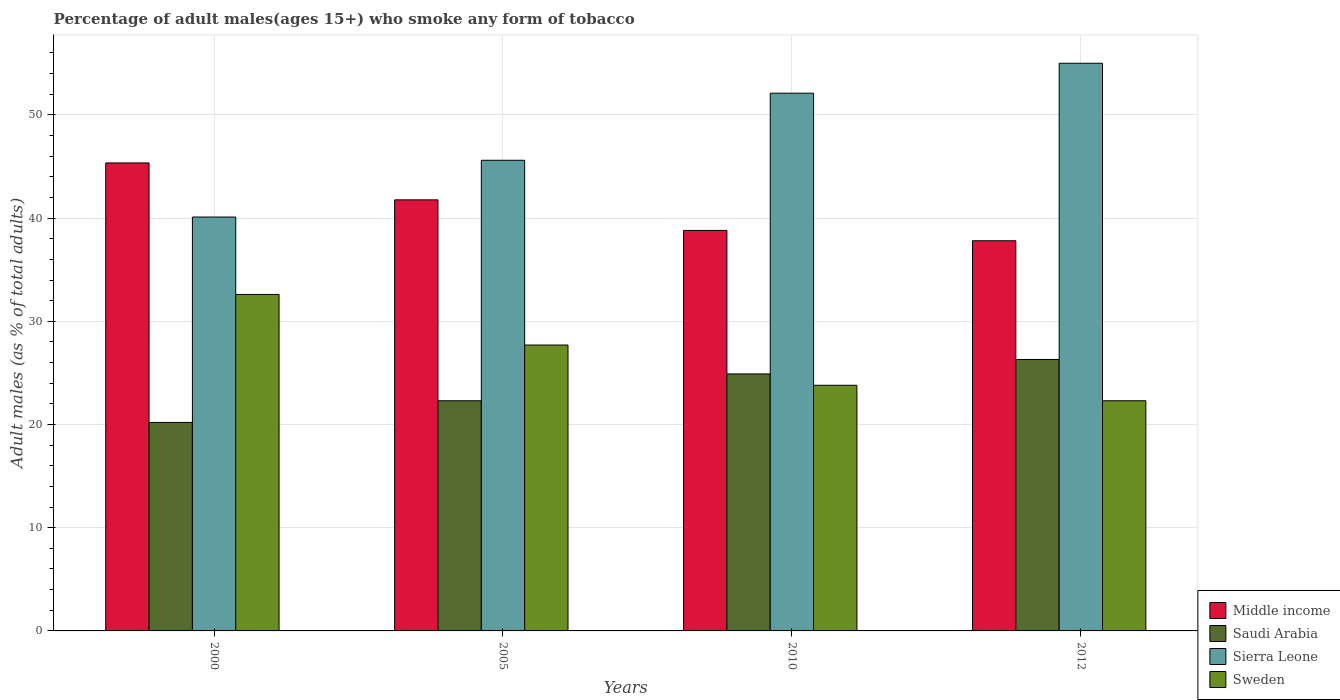Are the number of bars per tick equal to the number of legend labels?
Make the answer very short. Yes. Are the number of bars on each tick of the X-axis equal?
Your answer should be compact. Yes. How many bars are there on the 3rd tick from the right?
Your answer should be compact. 4. What is the label of the 3rd group of bars from the left?
Provide a succinct answer. 2010. What is the percentage of adult males who smoke in Sweden in 2000?
Make the answer very short. 32.6. Across all years, what is the maximum percentage of adult males who smoke in Saudi Arabia?
Your answer should be compact. 26.3. Across all years, what is the minimum percentage of adult males who smoke in Sweden?
Your answer should be very brief. 22.3. In which year was the percentage of adult males who smoke in Sierra Leone maximum?
Offer a very short reply. 2012. What is the total percentage of adult males who smoke in Middle income in the graph?
Provide a short and direct response. 163.71. What is the difference between the percentage of adult males who smoke in Sierra Leone in 2000 and the percentage of adult males who smoke in Sweden in 2005?
Your response must be concise. 12.4. What is the average percentage of adult males who smoke in Sierra Leone per year?
Ensure brevity in your answer.  48.2. In the year 2010, what is the difference between the percentage of adult males who smoke in Sweden and percentage of adult males who smoke in Sierra Leone?
Make the answer very short. -28.3. In how many years, is the percentage of adult males who smoke in Sierra Leone greater than 24 %?
Offer a terse response. 4. What is the ratio of the percentage of adult males who smoke in Sierra Leone in 2000 to that in 2010?
Provide a short and direct response. 0.77. Is the difference between the percentage of adult males who smoke in Sweden in 2000 and 2005 greater than the difference between the percentage of adult males who smoke in Sierra Leone in 2000 and 2005?
Ensure brevity in your answer.  Yes. What is the difference between the highest and the second highest percentage of adult males who smoke in Saudi Arabia?
Ensure brevity in your answer.  1.4. What is the difference between the highest and the lowest percentage of adult males who smoke in Sierra Leone?
Provide a succinct answer. 14.9. In how many years, is the percentage of adult males who smoke in Saudi Arabia greater than the average percentage of adult males who smoke in Saudi Arabia taken over all years?
Your response must be concise. 2. What does the 2nd bar from the left in 2012 represents?
Your answer should be compact. Saudi Arabia. What does the 2nd bar from the right in 2005 represents?
Offer a very short reply. Sierra Leone. How many bars are there?
Make the answer very short. 16. How many years are there in the graph?
Ensure brevity in your answer.  4. Are the values on the major ticks of Y-axis written in scientific E-notation?
Your answer should be very brief. No. Where does the legend appear in the graph?
Give a very brief answer. Bottom right. How many legend labels are there?
Ensure brevity in your answer.  4. What is the title of the graph?
Keep it short and to the point. Percentage of adult males(ages 15+) who smoke any form of tobacco. Does "Libya" appear as one of the legend labels in the graph?
Your answer should be compact. No. What is the label or title of the X-axis?
Make the answer very short. Years. What is the label or title of the Y-axis?
Keep it short and to the point. Adult males (as % of total adults). What is the Adult males (as % of total adults) in Middle income in 2000?
Your response must be concise. 45.34. What is the Adult males (as % of total adults) in Saudi Arabia in 2000?
Ensure brevity in your answer.  20.2. What is the Adult males (as % of total adults) of Sierra Leone in 2000?
Your answer should be very brief. 40.1. What is the Adult males (as % of total adults) in Sweden in 2000?
Your response must be concise. 32.6. What is the Adult males (as % of total adults) in Middle income in 2005?
Give a very brief answer. 41.77. What is the Adult males (as % of total adults) of Saudi Arabia in 2005?
Provide a short and direct response. 22.3. What is the Adult males (as % of total adults) in Sierra Leone in 2005?
Your answer should be compact. 45.6. What is the Adult males (as % of total adults) of Sweden in 2005?
Make the answer very short. 27.7. What is the Adult males (as % of total adults) of Middle income in 2010?
Provide a succinct answer. 38.8. What is the Adult males (as % of total adults) of Saudi Arabia in 2010?
Your answer should be very brief. 24.9. What is the Adult males (as % of total adults) in Sierra Leone in 2010?
Make the answer very short. 52.1. What is the Adult males (as % of total adults) of Sweden in 2010?
Provide a short and direct response. 23.8. What is the Adult males (as % of total adults) in Middle income in 2012?
Make the answer very short. 37.8. What is the Adult males (as % of total adults) of Saudi Arabia in 2012?
Keep it short and to the point. 26.3. What is the Adult males (as % of total adults) of Sierra Leone in 2012?
Provide a short and direct response. 55. What is the Adult males (as % of total adults) in Sweden in 2012?
Provide a succinct answer. 22.3. Across all years, what is the maximum Adult males (as % of total adults) of Middle income?
Make the answer very short. 45.34. Across all years, what is the maximum Adult males (as % of total adults) of Saudi Arabia?
Offer a very short reply. 26.3. Across all years, what is the maximum Adult males (as % of total adults) of Sweden?
Provide a short and direct response. 32.6. Across all years, what is the minimum Adult males (as % of total adults) of Middle income?
Provide a short and direct response. 37.8. Across all years, what is the minimum Adult males (as % of total adults) in Saudi Arabia?
Give a very brief answer. 20.2. Across all years, what is the minimum Adult males (as % of total adults) of Sierra Leone?
Offer a terse response. 40.1. Across all years, what is the minimum Adult males (as % of total adults) of Sweden?
Offer a terse response. 22.3. What is the total Adult males (as % of total adults) in Middle income in the graph?
Offer a terse response. 163.71. What is the total Adult males (as % of total adults) of Saudi Arabia in the graph?
Your answer should be very brief. 93.7. What is the total Adult males (as % of total adults) of Sierra Leone in the graph?
Offer a very short reply. 192.8. What is the total Adult males (as % of total adults) of Sweden in the graph?
Keep it short and to the point. 106.4. What is the difference between the Adult males (as % of total adults) in Middle income in 2000 and that in 2005?
Your answer should be compact. 3.58. What is the difference between the Adult males (as % of total adults) in Saudi Arabia in 2000 and that in 2005?
Ensure brevity in your answer.  -2.1. What is the difference between the Adult males (as % of total adults) in Sweden in 2000 and that in 2005?
Your answer should be very brief. 4.9. What is the difference between the Adult males (as % of total adults) of Middle income in 2000 and that in 2010?
Offer a very short reply. 6.54. What is the difference between the Adult males (as % of total adults) in Sierra Leone in 2000 and that in 2010?
Keep it short and to the point. -12. What is the difference between the Adult males (as % of total adults) in Middle income in 2000 and that in 2012?
Provide a short and direct response. 7.54. What is the difference between the Adult males (as % of total adults) in Sierra Leone in 2000 and that in 2012?
Give a very brief answer. -14.9. What is the difference between the Adult males (as % of total adults) in Middle income in 2005 and that in 2010?
Offer a terse response. 2.96. What is the difference between the Adult males (as % of total adults) of Saudi Arabia in 2005 and that in 2010?
Offer a very short reply. -2.6. What is the difference between the Adult males (as % of total adults) of Sierra Leone in 2005 and that in 2010?
Your response must be concise. -6.5. What is the difference between the Adult males (as % of total adults) in Middle income in 2005 and that in 2012?
Give a very brief answer. 3.96. What is the difference between the Adult males (as % of total adults) of Sierra Leone in 2005 and that in 2012?
Provide a succinct answer. -9.4. What is the difference between the Adult males (as % of total adults) of Middle income in 2000 and the Adult males (as % of total adults) of Saudi Arabia in 2005?
Your response must be concise. 23.04. What is the difference between the Adult males (as % of total adults) in Middle income in 2000 and the Adult males (as % of total adults) in Sierra Leone in 2005?
Keep it short and to the point. -0.26. What is the difference between the Adult males (as % of total adults) of Middle income in 2000 and the Adult males (as % of total adults) of Sweden in 2005?
Your answer should be very brief. 17.64. What is the difference between the Adult males (as % of total adults) in Saudi Arabia in 2000 and the Adult males (as % of total adults) in Sierra Leone in 2005?
Ensure brevity in your answer.  -25.4. What is the difference between the Adult males (as % of total adults) in Middle income in 2000 and the Adult males (as % of total adults) in Saudi Arabia in 2010?
Keep it short and to the point. 20.44. What is the difference between the Adult males (as % of total adults) of Middle income in 2000 and the Adult males (as % of total adults) of Sierra Leone in 2010?
Make the answer very short. -6.76. What is the difference between the Adult males (as % of total adults) of Middle income in 2000 and the Adult males (as % of total adults) of Sweden in 2010?
Your answer should be very brief. 21.54. What is the difference between the Adult males (as % of total adults) in Saudi Arabia in 2000 and the Adult males (as % of total adults) in Sierra Leone in 2010?
Ensure brevity in your answer.  -31.9. What is the difference between the Adult males (as % of total adults) in Saudi Arabia in 2000 and the Adult males (as % of total adults) in Sweden in 2010?
Your answer should be very brief. -3.6. What is the difference between the Adult males (as % of total adults) in Middle income in 2000 and the Adult males (as % of total adults) in Saudi Arabia in 2012?
Make the answer very short. 19.04. What is the difference between the Adult males (as % of total adults) in Middle income in 2000 and the Adult males (as % of total adults) in Sierra Leone in 2012?
Offer a very short reply. -9.66. What is the difference between the Adult males (as % of total adults) in Middle income in 2000 and the Adult males (as % of total adults) in Sweden in 2012?
Give a very brief answer. 23.04. What is the difference between the Adult males (as % of total adults) of Saudi Arabia in 2000 and the Adult males (as % of total adults) of Sierra Leone in 2012?
Provide a succinct answer. -34.8. What is the difference between the Adult males (as % of total adults) in Saudi Arabia in 2000 and the Adult males (as % of total adults) in Sweden in 2012?
Offer a terse response. -2.1. What is the difference between the Adult males (as % of total adults) in Middle income in 2005 and the Adult males (as % of total adults) in Saudi Arabia in 2010?
Provide a succinct answer. 16.87. What is the difference between the Adult males (as % of total adults) of Middle income in 2005 and the Adult males (as % of total adults) of Sierra Leone in 2010?
Keep it short and to the point. -10.33. What is the difference between the Adult males (as % of total adults) of Middle income in 2005 and the Adult males (as % of total adults) of Sweden in 2010?
Keep it short and to the point. 17.97. What is the difference between the Adult males (as % of total adults) in Saudi Arabia in 2005 and the Adult males (as % of total adults) in Sierra Leone in 2010?
Make the answer very short. -29.8. What is the difference between the Adult males (as % of total adults) of Sierra Leone in 2005 and the Adult males (as % of total adults) of Sweden in 2010?
Offer a very short reply. 21.8. What is the difference between the Adult males (as % of total adults) of Middle income in 2005 and the Adult males (as % of total adults) of Saudi Arabia in 2012?
Offer a very short reply. 15.47. What is the difference between the Adult males (as % of total adults) in Middle income in 2005 and the Adult males (as % of total adults) in Sierra Leone in 2012?
Your answer should be compact. -13.23. What is the difference between the Adult males (as % of total adults) of Middle income in 2005 and the Adult males (as % of total adults) of Sweden in 2012?
Give a very brief answer. 19.47. What is the difference between the Adult males (as % of total adults) of Saudi Arabia in 2005 and the Adult males (as % of total adults) of Sierra Leone in 2012?
Give a very brief answer. -32.7. What is the difference between the Adult males (as % of total adults) of Sierra Leone in 2005 and the Adult males (as % of total adults) of Sweden in 2012?
Give a very brief answer. 23.3. What is the difference between the Adult males (as % of total adults) in Middle income in 2010 and the Adult males (as % of total adults) in Saudi Arabia in 2012?
Your answer should be compact. 12.5. What is the difference between the Adult males (as % of total adults) in Middle income in 2010 and the Adult males (as % of total adults) in Sierra Leone in 2012?
Make the answer very short. -16.2. What is the difference between the Adult males (as % of total adults) in Middle income in 2010 and the Adult males (as % of total adults) in Sweden in 2012?
Offer a terse response. 16.5. What is the difference between the Adult males (as % of total adults) of Saudi Arabia in 2010 and the Adult males (as % of total adults) of Sierra Leone in 2012?
Keep it short and to the point. -30.1. What is the difference between the Adult males (as % of total adults) in Saudi Arabia in 2010 and the Adult males (as % of total adults) in Sweden in 2012?
Provide a short and direct response. 2.6. What is the difference between the Adult males (as % of total adults) of Sierra Leone in 2010 and the Adult males (as % of total adults) of Sweden in 2012?
Ensure brevity in your answer.  29.8. What is the average Adult males (as % of total adults) in Middle income per year?
Your answer should be very brief. 40.93. What is the average Adult males (as % of total adults) in Saudi Arabia per year?
Your answer should be compact. 23.43. What is the average Adult males (as % of total adults) in Sierra Leone per year?
Give a very brief answer. 48.2. What is the average Adult males (as % of total adults) in Sweden per year?
Your answer should be very brief. 26.6. In the year 2000, what is the difference between the Adult males (as % of total adults) in Middle income and Adult males (as % of total adults) in Saudi Arabia?
Provide a succinct answer. 25.14. In the year 2000, what is the difference between the Adult males (as % of total adults) of Middle income and Adult males (as % of total adults) of Sierra Leone?
Ensure brevity in your answer.  5.24. In the year 2000, what is the difference between the Adult males (as % of total adults) of Middle income and Adult males (as % of total adults) of Sweden?
Provide a short and direct response. 12.74. In the year 2000, what is the difference between the Adult males (as % of total adults) in Saudi Arabia and Adult males (as % of total adults) in Sierra Leone?
Ensure brevity in your answer.  -19.9. In the year 2000, what is the difference between the Adult males (as % of total adults) of Sierra Leone and Adult males (as % of total adults) of Sweden?
Provide a short and direct response. 7.5. In the year 2005, what is the difference between the Adult males (as % of total adults) of Middle income and Adult males (as % of total adults) of Saudi Arabia?
Ensure brevity in your answer.  19.47. In the year 2005, what is the difference between the Adult males (as % of total adults) in Middle income and Adult males (as % of total adults) in Sierra Leone?
Offer a very short reply. -3.83. In the year 2005, what is the difference between the Adult males (as % of total adults) of Middle income and Adult males (as % of total adults) of Sweden?
Your answer should be very brief. 14.07. In the year 2005, what is the difference between the Adult males (as % of total adults) of Saudi Arabia and Adult males (as % of total adults) of Sierra Leone?
Ensure brevity in your answer.  -23.3. In the year 2010, what is the difference between the Adult males (as % of total adults) in Middle income and Adult males (as % of total adults) in Saudi Arabia?
Offer a very short reply. 13.9. In the year 2010, what is the difference between the Adult males (as % of total adults) of Middle income and Adult males (as % of total adults) of Sierra Leone?
Give a very brief answer. -13.3. In the year 2010, what is the difference between the Adult males (as % of total adults) in Middle income and Adult males (as % of total adults) in Sweden?
Provide a short and direct response. 15. In the year 2010, what is the difference between the Adult males (as % of total adults) of Saudi Arabia and Adult males (as % of total adults) of Sierra Leone?
Offer a terse response. -27.2. In the year 2010, what is the difference between the Adult males (as % of total adults) in Sierra Leone and Adult males (as % of total adults) in Sweden?
Give a very brief answer. 28.3. In the year 2012, what is the difference between the Adult males (as % of total adults) of Middle income and Adult males (as % of total adults) of Saudi Arabia?
Offer a very short reply. 11.5. In the year 2012, what is the difference between the Adult males (as % of total adults) of Middle income and Adult males (as % of total adults) of Sierra Leone?
Give a very brief answer. -17.2. In the year 2012, what is the difference between the Adult males (as % of total adults) of Middle income and Adult males (as % of total adults) of Sweden?
Keep it short and to the point. 15.5. In the year 2012, what is the difference between the Adult males (as % of total adults) of Saudi Arabia and Adult males (as % of total adults) of Sierra Leone?
Keep it short and to the point. -28.7. In the year 2012, what is the difference between the Adult males (as % of total adults) in Sierra Leone and Adult males (as % of total adults) in Sweden?
Offer a terse response. 32.7. What is the ratio of the Adult males (as % of total adults) of Middle income in 2000 to that in 2005?
Your answer should be very brief. 1.09. What is the ratio of the Adult males (as % of total adults) of Saudi Arabia in 2000 to that in 2005?
Provide a short and direct response. 0.91. What is the ratio of the Adult males (as % of total adults) of Sierra Leone in 2000 to that in 2005?
Provide a succinct answer. 0.88. What is the ratio of the Adult males (as % of total adults) of Sweden in 2000 to that in 2005?
Offer a very short reply. 1.18. What is the ratio of the Adult males (as % of total adults) of Middle income in 2000 to that in 2010?
Offer a terse response. 1.17. What is the ratio of the Adult males (as % of total adults) of Saudi Arabia in 2000 to that in 2010?
Offer a terse response. 0.81. What is the ratio of the Adult males (as % of total adults) in Sierra Leone in 2000 to that in 2010?
Ensure brevity in your answer.  0.77. What is the ratio of the Adult males (as % of total adults) of Sweden in 2000 to that in 2010?
Offer a terse response. 1.37. What is the ratio of the Adult males (as % of total adults) in Middle income in 2000 to that in 2012?
Keep it short and to the point. 1.2. What is the ratio of the Adult males (as % of total adults) in Saudi Arabia in 2000 to that in 2012?
Your answer should be very brief. 0.77. What is the ratio of the Adult males (as % of total adults) in Sierra Leone in 2000 to that in 2012?
Offer a very short reply. 0.73. What is the ratio of the Adult males (as % of total adults) of Sweden in 2000 to that in 2012?
Your answer should be compact. 1.46. What is the ratio of the Adult males (as % of total adults) in Middle income in 2005 to that in 2010?
Your answer should be compact. 1.08. What is the ratio of the Adult males (as % of total adults) of Saudi Arabia in 2005 to that in 2010?
Offer a terse response. 0.9. What is the ratio of the Adult males (as % of total adults) of Sierra Leone in 2005 to that in 2010?
Give a very brief answer. 0.88. What is the ratio of the Adult males (as % of total adults) in Sweden in 2005 to that in 2010?
Your answer should be very brief. 1.16. What is the ratio of the Adult males (as % of total adults) of Middle income in 2005 to that in 2012?
Offer a very short reply. 1.1. What is the ratio of the Adult males (as % of total adults) in Saudi Arabia in 2005 to that in 2012?
Provide a succinct answer. 0.85. What is the ratio of the Adult males (as % of total adults) in Sierra Leone in 2005 to that in 2012?
Offer a very short reply. 0.83. What is the ratio of the Adult males (as % of total adults) of Sweden in 2005 to that in 2012?
Your response must be concise. 1.24. What is the ratio of the Adult males (as % of total adults) of Middle income in 2010 to that in 2012?
Ensure brevity in your answer.  1.03. What is the ratio of the Adult males (as % of total adults) of Saudi Arabia in 2010 to that in 2012?
Give a very brief answer. 0.95. What is the ratio of the Adult males (as % of total adults) in Sierra Leone in 2010 to that in 2012?
Your answer should be very brief. 0.95. What is the ratio of the Adult males (as % of total adults) of Sweden in 2010 to that in 2012?
Offer a terse response. 1.07. What is the difference between the highest and the second highest Adult males (as % of total adults) of Middle income?
Keep it short and to the point. 3.58. What is the difference between the highest and the second highest Adult males (as % of total adults) of Saudi Arabia?
Your answer should be very brief. 1.4. What is the difference between the highest and the second highest Adult males (as % of total adults) in Sierra Leone?
Your answer should be very brief. 2.9. What is the difference between the highest and the lowest Adult males (as % of total adults) of Middle income?
Your answer should be very brief. 7.54. What is the difference between the highest and the lowest Adult males (as % of total adults) in Saudi Arabia?
Provide a short and direct response. 6.1. What is the difference between the highest and the lowest Adult males (as % of total adults) of Sierra Leone?
Offer a terse response. 14.9. What is the difference between the highest and the lowest Adult males (as % of total adults) in Sweden?
Your response must be concise. 10.3. 